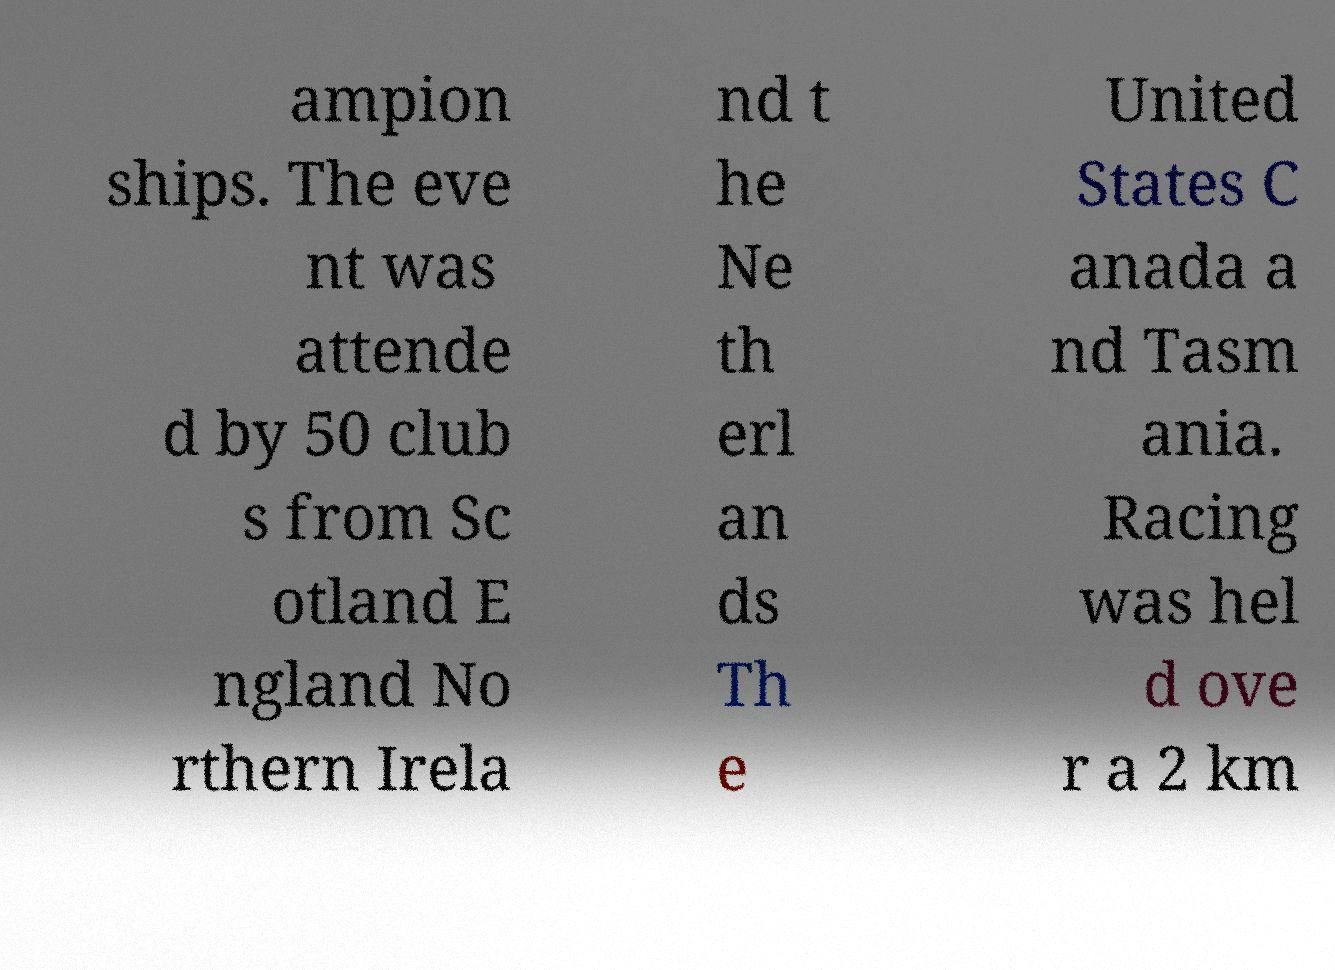There's text embedded in this image that I need extracted. Can you transcribe it verbatim? ampion ships. The eve nt was attende d by 50 club s from Sc otland E ngland No rthern Irela nd t he Ne th erl an ds Th e United States C anada a nd Tasm ania. Racing was hel d ove r a 2 km 